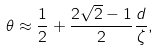Convert formula to latex. <formula><loc_0><loc_0><loc_500><loc_500>\theta \approx \frac { 1 } { 2 } + \frac { 2 \sqrt { 2 } - 1 } { 2 } \frac { d } { \zeta } ,</formula> 